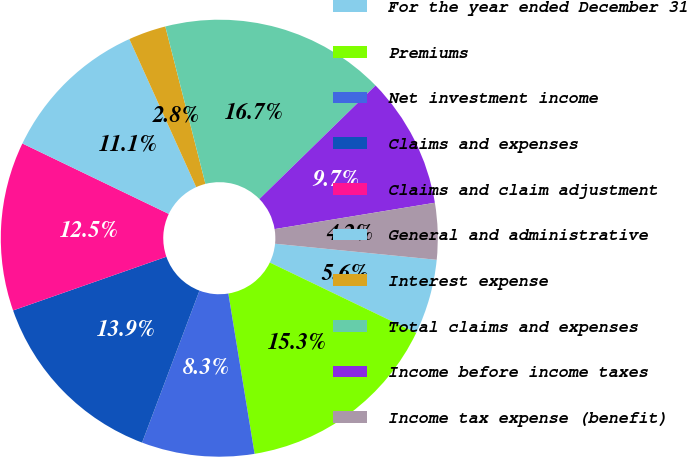Convert chart to OTSL. <chart><loc_0><loc_0><loc_500><loc_500><pie_chart><fcel>For the year ended December 31<fcel>Premiums<fcel>Net investment income<fcel>Claims and expenses<fcel>Claims and claim adjustment<fcel>General and administrative<fcel>Interest expense<fcel>Total claims and expenses<fcel>Income before income taxes<fcel>Income tax expense (benefit)<nl><fcel>5.56%<fcel>15.28%<fcel>8.33%<fcel>13.89%<fcel>12.5%<fcel>11.11%<fcel>2.78%<fcel>16.66%<fcel>9.72%<fcel>4.17%<nl></chart> 